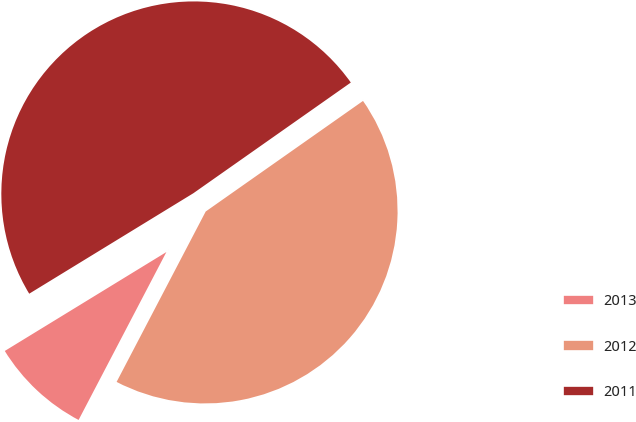Convert chart. <chart><loc_0><loc_0><loc_500><loc_500><pie_chart><fcel>2013<fcel>2012<fcel>2011<nl><fcel>8.59%<fcel>42.42%<fcel>48.99%<nl></chart> 